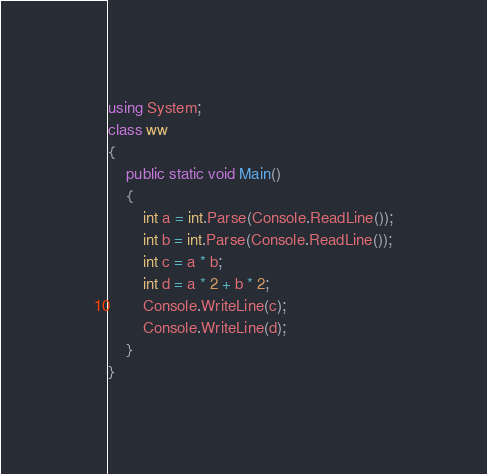<code> <loc_0><loc_0><loc_500><loc_500><_C#_>using System;
class ww
{
    public static void Main()
    {
        int a = int.Parse(Console.ReadLine());
        int b = int.Parse(Console.ReadLine());
        int c = a * b;
        int d = a * 2 + b * 2;
        Console.WriteLine(c);
        Console.WriteLine(d);
    }
}</code> 